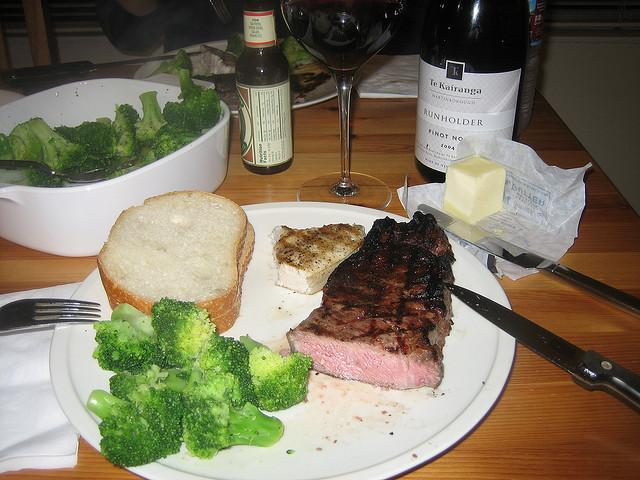How is this steak cooked? medium 